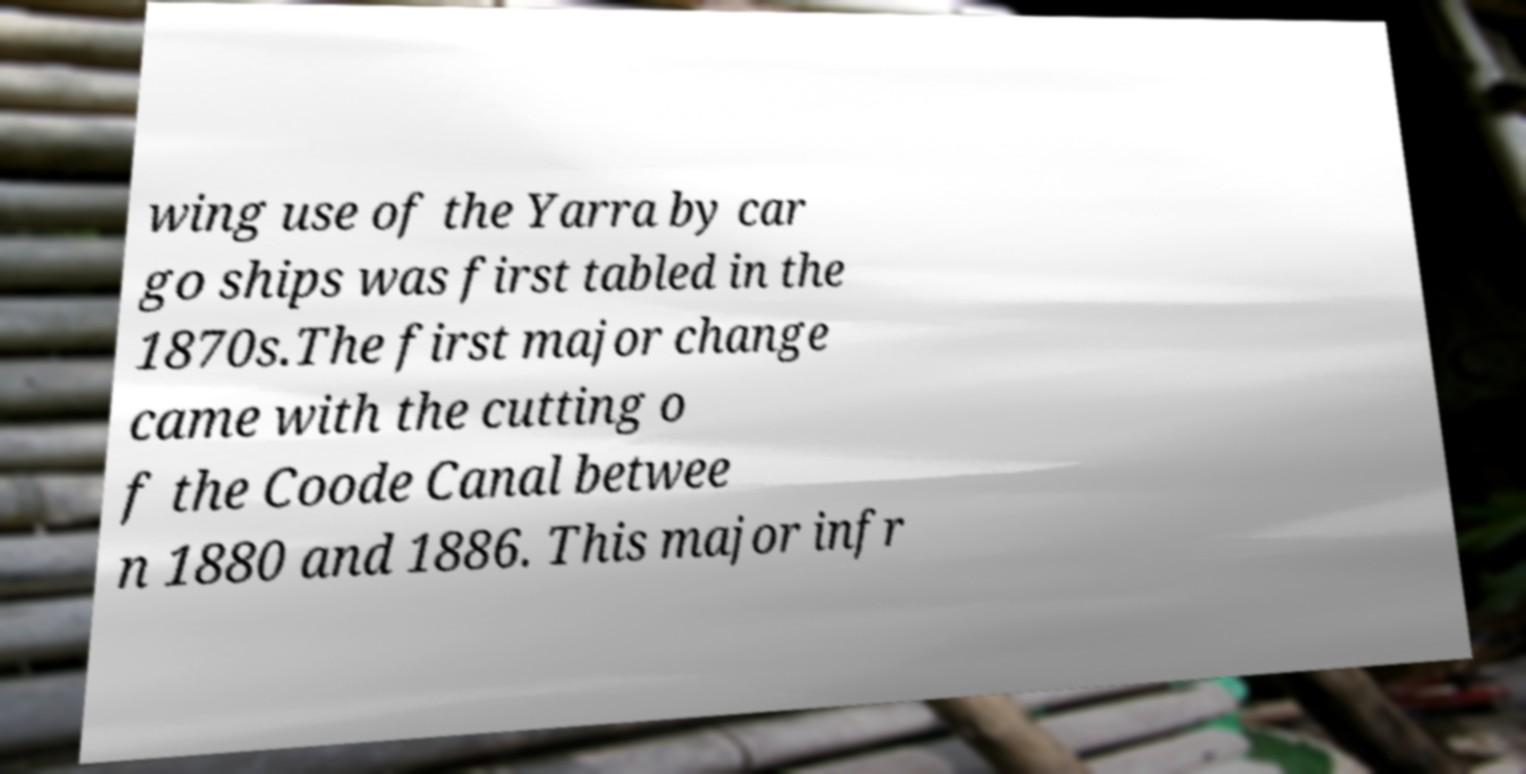Could you assist in decoding the text presented in this image and type it out clearly? wing use of the Yarra by car go ships was first tabled in the 1870s.The first major change came with the cutting o f the Coode Canal betwee n 1880 and 1886. This major infr 